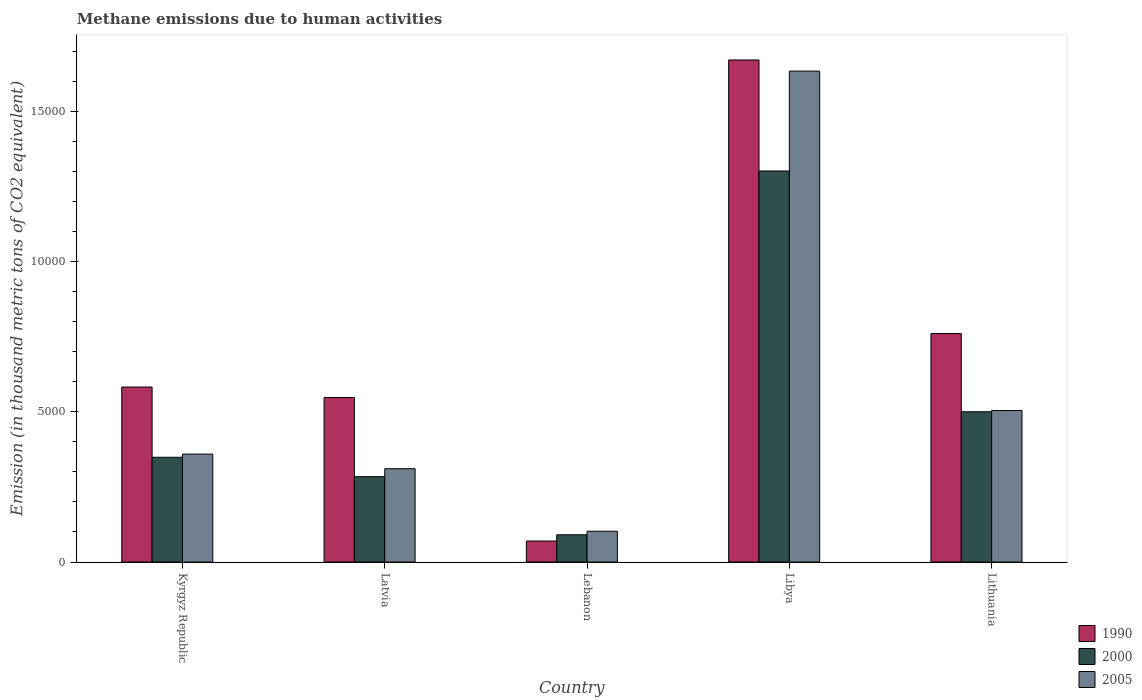How many different coloured bars are there?
Your response must be concise. 3. How many bars are there on the 5th tick from the left?
Your answer should be very brief. 3. How many bars are there on the 4th tick from the right?
Provide a short and direct response. 3. What is the label of the 4th group of bars from the left?
Keep it short and to the point. Libya. What is the amount of methane emitted in 1990 in Latvia?
Ensure brevity in your answer.  5472.8. Across all countries, what is the maximum amount of methane emitted in 2000?
Provide a short and direct response. 1.30e+04. Across all countries, what is the minimum amount of methane emitted in 2005?
Give a very brief answer. 1024.8. In which country was the amount of methane emitted in 2000 maximum?
Your response must be concise. Libya. In which country was the amount of methane emitted in 1990 minimum?
Offer a very short reply. Lebanon. What is the total amount of methane emitted in 2005 in the graph?
Your answer should be very brief. 2.91e+04. What is the difference between the amount of methane emitted in 2000 in Lebanon and that in Libya?
Keep it short and to the point. -1.21e+04. What is the difference between the amount of methane emitted in 2005 in Libya and the amount of methane emitted in 1990 in Latvia?
Offer a terse response. 1.09e+04. What is the average amount of methane emitted in 2005 per country?
Provide a short and direct response. 5819.52. What is the difference between the amount of methane emitted of/in 1990 and amount of methane emitted of/in 2005 in Lebanon?
Your answer should be compact. -325.8. In how many countries, is the amount of methane emitted in 2005 greater than 8000 thousand metric tons?
Your answer should be compact. 1. What is the ratio of the amount of methane emitted in 2000 in Latvia to that in Lebanon?
Provide a short and direct response. 3.13. Is the difference between the amount of methane emitted in 1990 in Libya and Lithuania greater than the difference between the amount of methane emitted in 2005 in Libya and Lithuania?
Your response must be concise. No. What is the difference between the highest and the second highest amount of methane emitted in 2005?
Offer a very short reply. -1.13e+04. What is the difference between the highest and the lowest amount of methane emitted in 1990?
Offer a very short reply. 1.60e+04. Is the sum of the amount of methane emitted in 2005 in Libya and Lithuania greater than the maximum amount of methane emitted in 2000 across all countries?
Offer a terse response. Yes. What does the 2nd bar from the left in Latvia represents?
Your answer should be very brief. 2000. How many bars are there?
Your answer should be very brief. 15. Does the graph contain any zero values?
Provide a succinct answer. No. How many legend labels are there?
Offer a very short reply. 3. How are the legend labels stacked?
Offer a terse response. Vertical. What is the title of the graph?
Keep it short and to the point. Methane emissions due to human activities. What is the label or title of the Y-axis?
Provide a short and direct response. Emission (in thousand metric tons of CO2 equivalent). What is the Emission (in thousand metric tons of CO2 equivalent) of 1990 in Kyrgyz Republic?
Give a very brief answer. 5822.6. What is the Emission (in thousand metric tons of CO2 equivalent) of 2000 in Kyrgyz Republic?
Ensure brevity in your answer.  3485.8. What is the Emission (in thousand metric tons of CO2 equivalent) of 2005 in Kyrgyz Republic?
Ensure brevity in your answer.  3591.3. What is the Emission (in thousand metric tons of CO2 equivalent) in 1990 in Latvia?
Offer a very short reply. 5472.8. What is the Emission (in thousand metric tons of CO2 equivalent) of 2000 in Latvia?
Offer a terse response. 2840. What is the Emission (in thousand metric tons of CO2 equivalent) in 2005 in Latvia?
Give a very brief answer. 3105. What is the Emission (in thousand metric tons of CO2 equivalent) of 1990 in Lebanon?
Provide a short and direct response. 699. What is the Emission (in thousand metric tons of CO2 equivalent) of 2000 in Lebanon?
Your answer should be very brief. 906.6. What is the Emission (in thousand metric tons of CO2 equivalent) in 2005 in Lebanon?
Provide a short and direct response. 1024.8. What is the Emission (in thousand metric tons of CO2 equivalent) in 1990 in Libya?
Offer a very short reply. 1.67e+04. What is the Emission (in thousand metric tons of CO2 equivalent) of 2000 in Libya?
Your answer should be very brief. 1.30e+04. What is the Emission (in thousand metric tons of CO2 equivalent) in 2005 in Libya?
Provide a succinct answer. 1.63e+04. What is the Emission (in thousand metric tons of CO2 equivalent) of 1990 in Lithuania?
Your answer should be very brief. 7603.6. What is the Emission (in thousand metric tons of CO2 equivalent) of 2000 in Lithuania?
Keep it short and to the point. 5000.2. What is the Emission (in thousand metric tons of CO2 equivalent) of 2005 in Lithuania?
Offer a terse response. 5042.2. Across all countries, what is the maximum Emission (in thousand metric tons of CO2 equivalent) in 1990?
Keep it short and to the point. 1.67e+04. Across all countries, what is the maximum Emission (in thousand metric tons of CO2 equivalent) in 2000?
Your answer should be very brief. 1.30e+04. Across all countries, what is the maximum Emission (in thousand metric tons of CO2 equivalent) in 2005?
Your answer should be compact. 1.63e+04. Across all countries, what is the minimum Emission (in thousand metric tons of CO2 equivalent) of 1990?
Provide a short and direct response. 699. Across all countries, what is the minimum Emission (in thousand metric tons of CO2 equivalent) in 2000?
Keep it short and to the point. 906.6. Across all countries, what is the minimum Emission (in thousand metric tons of CO2 equivalent) of 2005?
Offer a terse response. 1024.8. What is the total Emission (in thousand metric tons of CO2 equivalent) of 1990 in the graph?
Your answer should be very brief. 3.63e+04. What is the total Emission (in thousand metric tons of CO2 equivalent) of 2000 in the graph?
Provide a short and direct response. 2.52e+04. What is the total Emission (in thousand metric tons of CO2 equivalent) of 2005 in the graph?
Provide a succinct answer. 2.91e+04. What is the difference between the Emission (in thousand metric tons of CO2 equivalent) in 1990 in Kyrgyz Republic and that in Latvia?
Provide a short and direct response. 349.8. What is the difference between the Emission (in thousand metric tons of CO2 equivalent) in 2000 in Kyrgyz Republic and that in Latvia?
Make the answer very short. 645.8. What is the difference between the Emission (in thousand metric tons of CO2 equivalent) in 2005 in Kyrgyz Republic and that in Latvia?
Provide a short and direct response. 486.3. What is the difference between the Emission (in thousand metric tons of CO2 equivalent) in 1990 in Kyrgyz Republic and that in Lebanon?
Offer a terse response. 5123.6. What is the difference between the Emission (in thousand metric tons of CO2 equivalent) in 2000 in Kyrgyz Republic and that in Lebanon?
Offer a terse response. 2579.2. What is the difference between the Emission (in thousand metric tons of CO2 equivalent) in 2005 in Kyrgyz Republic and that in Lebanon?
Keep it short and to the point. 2566.5. What is the difference between the Emission (in thousand metric tons of CO2 equivalent) of 1990 in Kyrgyz Republic and that in Libya?
Make the answer very short. -1.09e+04. What is the difference between the Emission (in thousand metric tons of CO2 equivalent) of 2000 in Kyrgyz Republic and that in Libya?
Make the answer very short. -9525.3. What is the difference between the Emission (in thousand metric tons of CO2 equivalent) in 2005 in Kyrgyz Republic and that in Libya?
Keep it short and to the point. -1.27e+04. What is the difference between the Emission (in thousand metric tons of CO2 equivalent) in 1990 in Kyrgyz Republic and that in Lithuania?
Provide a succinct answer. -1781. What is the difference between the Emission (in thousand metric tons of CO2 equivalent) of 2000 in Kyrgyz Republic and that in Lithuania?
Keep it short and to the point. -1514.4. What is the difference between the Emission (in thousand metric tons of CO2 equivalent) in 2005 in Kyrgyz Republic and that in Lithuania?
Your answer should be compact. -1450.9. What is the difference between the Emission (in thousand metric tons of CO2 equivalent) of 1990 in Latvia and that in Lebanon?
Offer a terse response. 4773.8. What is the difference between the Emission (in thousand metric tons of CO2 equivalent) in 2000 in Latvia and that in Lebanon?
Make the answer very short. 1933.4. What is the difference between the Emission (in thousand metric tons of CO2 equivalent) of 2005 in Latvia and that in Lebanon?
Provide a short and direct response. 2080.2. What is the difference between the Emission (in thousand metric tons of CO2 equivalent) in 1990 in Latvia and that in Libya?
Ensure brevity in your answer.  -1.12e+04. What is the difference between the Emission (in thousand metric tons of CO2 equivalent) of 2000 in Latvia and that in Libya?
Keep it short and to the point. -1.02e+04. What is the difference between the Emission (in thousand metric tons of CO2 equivalent) of 2005 in Latvia and that in Libya?
Keep it short and to the point. -1.32e+04. What is the difference between the Emission (in thousand metric tons of CO2 equivalent) in 1990 in Latvia and that in Lithuania?
Keep it short and to the point. -2130.8. What is the difference between the Emission (in thousand metric tons of CO2 equivalent) in 2000 in Latvia and that in Lithuania?
Give a very brief answer. -2160.2. What is the difference between the Emission (in thousand metric tons of CO2 equivalent) of 2005 in Latvia and that in Lithuania?
Make the answer very short. -1937.2. What is the difference between the Emission (in thousand metric tons of CO2 equivalent) in 1990 in Lebanon and that in Libya?
Give a very brief answer. -1.60e+04. What is the difference between the Emission (in thousand metric tons of CO2 equivalent) of 2000 in Lebanon and that in Libya?
Offer a terse response. -1.21e+04. What is the difference between the Emission (in thousand metric tons of CO2 equivalent) of 2005 in Lebanon and that in Libya?
Give a very brief answer. -1.53e+04. What is the difference between the Emission (in thousand metric tons of CO2 equivalent) in 1990 in Lebanon and that in Lithuania?
Your answer should be very brief. -6904.6. What is the difference between the Emission (in thousand metric tons of CO2 equivalent) in 2000 in Lebanon and that in Lithuania?
Give a very brief answer. -4093.6. What is the difference between the Emission (in thousand metric tons of CO2 equivalent) in 2005 in Lebanon and that in Lithuania?
Provide a succinct answer. -4017.4. What is the difference between the Emission (in thousand metric tons of CO2 equivalent) in 1990 in Libya and that in Lithuania?
Give a very brief answer. 9100.8. What is the difference between the Emission (in thousand metric tons of CO2 equivalent) in 2000 in Libya and that in Lithuania?
Offer a terse response. 8010.9. What is the difference between the Emission (in thousand metric tons of CO2 equivalent) of 2005 in Libya and that in Lithuania?
Your answer should be very brief. 1.13e+04. What is the difference between the Emission (in thousand metric tons of CO2 equivalent) of 1990 in Kyrgyz Republic and the Emission (in thousand metric tons of CO2 equivalent) of 2000 in Latvia?
Your answer should be very brief. 2982.6. What is the difference between the Emission (in thousand metric tons of CO2 equivalent) of 1990 in Kyrgyz Republic and the Emission (in thousand metric tons of CO2 equivalent) of 2005 in Latvia?
Your response must be concise. 2717.6. What is the difference between the Emission (in thousand metric tons of CO2 equivalent) of 2000 in Kyrgyz Republic and the Emission (in thousand metric tons of CO2 equivalent) of 2005 in Latvia?
Provide a succinct answer. 380.8. What is the difference between the Emission (in thousand metric tons of CO2 equivalent) of 1990 in Kyrgyz Republic and the Emission (in thousand metric tons of CO2 equivalent) of 2000 in Lebanon?
Keep it short and to the point. 4916. What is the difference between the Emission (in thousand metric tons of CO2 equivalent) in 1990 in Kyrgyz Republic and the Emission (in thousand metric tons of CO2 equivalent) in 2005 in Lebanon?
Keep it short and to the point. 4797.8. What is the difference between the Emission (in thousand metric tons of CO2 equivalent) in 2000 in Kyrgyz Republic and the Emission (in thousand metric tons of CO2 equivalent) in 2005 in Lebanon?
Ensure brevity in your answer.  2461. What is the difference between the Emission (in thousand metric tons of CO2 equivalent) in 1990 in Kyrgyz Republic and the Emission (in thousand metric tons of CO2 equivalent) in 2000 in Libya?
Your response must be concise. -7188.5. What is the difference between the Emission (in thousand metric tons of CO2 equivalent) of 1990 in Kyrgyz Republic and the Emission (in thousand metric tons of CO2 equivalent) of 2005 in Libya?
Give a very brief answer. -1.05e+04. What is the difference between the Emission (in thousand metric tons of CO2 equivalent) in 2000 in Kyrgyz Republic and the Emission (in thousand metric tons of CO2 equivalent) in 2005 in Libya?
Your response must be concise. -1.28e+04. What is the difference between the Emission (in thousand metric tons of CO2 equivalent) of 1990 in Kyrgyz Republic and the Emission (in thousand metric tons of CO2 equivalent) of 2000 in Lithuania?
Offer a terse response. 822.4. What is the difference between the Emission (in thousand metric tons of CO2 equivalent) in 1990 in Kyrgyz Republic and the Emission (in thousand metric tons of CO2 equivalent) in 2005 in Lithuania?
Ensure brevity in your answer.  780.4. What is the difference between the Emission (in thousand metric tons of CO2 equivalent) of 2000 in Kyrgyz Republic and the Emission (in thousand metric tons of CO2 equivalent) of 2005 in Lithuania?
Provide a succinct answer. -1556.4. What is the difference between the Emission (in thousand metric tons of CO2 equivalent) of 1990 in Latvia and the Emission (in thousand metric tons of CO2 equivalent) of 2000 in Lebanon?
Offer a very short reply. 4566.2. What is the difference between the Emission (in thousand metric tons of CO2 equivalent) of 1990 in Latvia and the Emission (in thousand metric tons of CO2 equivalent) of 2005 in Lebanon?
Ensure brevity in your answer.  4448. What is the difference between the Emission (in thousand metric tons of CO2 equivalent) of 2000 in Latvia and the Emission (in thousand metric tons of CO2 equivalent) of 2005 in Lebanon?
Make the answer very short. 1815.2. What is the difference between the Emission (in thousand metric tons of CO2 equivalent) of 1990 in Latvia and the Emission (in thousand metric tons of CO2 equivalent) of 2000 in Libya?
Offer a very short reply. -7538.3. What is the difference between the Emission (in thousand metric tons of CO2 equivalent) of 1990 in Latvia and the Emission (in thousand metric tons of CO2 equivalent) of 2005 in Libya?
Provide a succinct answer. -1.09e+04. What is the difference between the Emission (in thousand metric tons of CO2 equivalent) in 2000 in Latvia and the Emission (in thousand metric tons of CO2 equivalent) in 2005 in Libya?
Make the answer very short. -1.35e+04. What is the difference between the Emission (in thousand metric tons of CO2 equivalent) in 1990 in Latvia and the Emission (in thousand metric tons of CO2 equivalent) in 2000 in Lithuania?
Keep it short and to the point. 472.6. What is the difference between the Emission (in thousand metric tons of CO2 equivalent) in 1990 in Latvia and the Emission (in thousand metric tons of CO2 equivalent) in 2005 in Lithuania?
Provide a short and direct response. 430.6. What is the difference between the Emission (in thousand metric tons of CO2 equivalent) in 2000 in Latvia and the Emission (in thousand metric tons of CO2 equivalent) in 2005 in Lithuania?
Provide a short and direct response. -2202.2. What is the difference between the Emission (in thousand metric tons of CO2 equivalent) of 1990 in Lebanon and the Emission (in thousand metric tons of CO2 equivalent) of 2000 in Libya?
Provide a short and direct response. -1.23e+04. What is the difference between the Emission (in thousand metric tons of CO2 equivalent) in 1990 in Lebanon and the Emission (in thousand metric tons of CO2 equivalent) in 2005 in Libya?
Provide a succinct answer. -1.56e+04. What is the difference between the Emission (in thousand metric tons of CO2 equivalent) of 2000 in Lebanon and the Emission (in thousand metric tons of CO2 equivalent) of 2005 in Libya?
Your response must be concise. -1.54e+04. What is the difference between the Emission (in thousand metric tons of CO2 equivalent) of 1990 in Lebanon and the Emission (in thousand metric tons of CO2 equivalent) of 2000 in Lithuania?
Your response must be concise. -4301.2. What is the difference between the Emission (in thousand metric tons of CO2 equivalent) in 1990 in Lebanon and the Emission (in thousand metric tons of CO2 equivalent) in 2005 in Lithuania?
Your response must be concise. -4343.2. What is the difference between the Emission (in thousand metric tons of CO2 equivalent) in 2000 in Lebanon and the Emission (in thousand metric tons of CO2 equivalent) in 2005 in Lithuania?
Your answer should be compact. -4135.6. What is the difference between the Emission (in thousand metric tons of CO2 equivalent) of 1990 in Libya and the Emission (in thousand metric tons of CO2 equivalent) of 2000 in Lithuania?
Provide a short and direct response. 1.17e+04. What is the difference between the Emission (in thousand metric tons of CO2 equivalent) of 1990 in Libya and the Emission (in thousand metric tons of CO2 equivalent) of 2005 in Lithuania?
Keep it short and to the point. 1.17e+04. What is the difference between the Emission (in thousand metric tons of CO2 equivalent) in 2000 in Libya and the Emission (in thousand metric tons of CO2 equivalent) in 2005 in Lithuania?
Provide a short and direct response. 7968.9. What is the average Emission (in thousand metric tons of CO2 equivalent) of 1990 per country?
Provide a short and direct response. 7260.48. What is the average Emission (in thousand metric tons of CO2 equivalent) of 2000 per country?
Provide a succinct answer. 5048.74. What is the average Emission (in thousand metric tons of CO2 equivalent) of 2005 per country?
Give a very brief answer. 5819.52. What is the difference between the Emission (in thousand metric tons of CO2 equivalent) in 1990 and Emission (in thousand metric tons of CO2 equivalent) in 2000 in Kyrgyz Republic?
Your response must be concise. 2336.8. What is the difference between the Emission (in thousand metric tons of CO2 equivalent) in 1990 and Emission (in thousand metric tons of CO2 equivalent) in 2005 in Kyrgyz Republic?
Your answer should be compact. 2231.3. What is the difference between the Emission (in thousand metric tons of CO2 equivalent) in 2000 and Emission (in thousand metric tons of CO2 equivalent) in 2005 in Kyrgyz Republic?
Keep it short and to the point. -105.5. What is the difference between the Emission (in thousand metric tons of CO2 equivalent) in 1990 and Emission (in thousand metric tons of CO2 equivalent) in 2000 in Latvia?
Offer a terse response. 2632.8. What is the difference between the Emission (in thousand metric tons of CO2 equivalent) of 1990 and Emission (in thousand metric tons of CO2 equivalent) of 2005 in Latvia?
Your answer should be compact. 2367.8. What is the difference between the Emission (in thousand metric tons of CO2 equivalent) in 2000 and Emission (in thousand metric tons of CO2 equivalent) in 2005 in Latvia?
Provide a succinct answer. -265. What is the difference between the Emission (in thousand metric tons of CO2 equivalent) of 1990 and Emission (in thousand metric tons of CO2 equivalent) of 2000 in Lebanon?
Offer a terse response. -207.6. What is the difference between the Emission (in thousand metric tons of CO2 equivalent) in 1990 and Emission (in thousand metric tons of CO2 equivalent) in 2005 in Lebanon?
Your answer should be compact. -325.8. What is the difference between the Emission (in thousand metric tons of CO2 equivalent) of 2000 and Emission (in thousand metric tons of CO2 equivalent) of 2005 in Lebanon?
Provide a succinct answer. -118.2. What is the difference between the Emission (in thousand metric tons of CO2 equivalent) in 1990 and Emission (in thousand metric tons of CO2 equivalent) in 2000 in Libya?
Ensure brevity in your answer.  3693.3. What is the difference between the Emission (in thousand metric tons of CO2 equivalent) of 1990 and Emission (in thousand metric tons of CO2 equivalent) of 2005 in Libya?
Your answer should be very brief. 370.1. What is the difference between the Emission (in thousand metric tons of CO2 equivalent) in 2000 and Emission (in thousand metric tons of CO2 equivalent) in 2005 in Libya?
Offer a very short reply. -3323.2. What is the difference between the Emission (in thousand metric tons of CO2 equivalent) in 1990 and Emission (in thousand metric tons of CO2 equivalent) in 2000 in Lithuania?
Provide a short and direct response. 2603.4. What is the difference between the Emission (in thousand metric tons of CO2 equivalent) of 1990 and Emission (in thousand metric tons of CO2 equivalent) of 2005 in Lithuania?
Ensure brevity in your answer.  2561.4. What is the difference between the Emission (in thousand metric tons of CO2 equivalent) in 2000 and Emission (in thousand metric tons of CO2 equivalent) in 2005 in Lithuania?
Your response must be concise. -42. What is the ratio of the Emission (in thousand metric tons of CO2 equivalent) of 1990 in Kyrgyz Republic to that in Latvia?
Your answer should be compact. 1.06. What is the ratio of the Emission (in thousand metric tons of CO2 equivalent) of 2000 in Kyrgyz Republic to that in Latvia?
Provide a short and direct response. 1.23. What is the ratio of the Emission (in thousand metric tons of CO2 equivalent) in 2005 in Kyrgyz Republic to that in Latvia?
Your response must be concise. 1.16. What is the ratio of the Emission (in thousand metric tons of CO2 equivalent) in 1990 in Kyrgyz Republic to that in Lebanon?
Your answer should be compact. 8.33. What is the ratio of the Emission (in thousand metric tons of CO2 equivalent) of 2000 in Kyrgyz Republic to that in Lebanon?
Provide a short and direct response. 3.84. What is the ratio of the Emission (in thousand metric tons of CO2 equivalent) in 2005 in Kyrgyz Republic to that in Lebanon?
Offer a terse response. 3.5. What is the ratio of the Emission (in thousand metric tons of CO2 equivalent) in 1990 in Kyrgyz Republic to that in Libya?
Provide a succinct answer. 0.35. What is the ratio of the Emission (in thousand metric tons of CO2 equivalent) of 2000 in Kyrgyz Republic to that in Libya?
Your answer should be very brief. 0.27. What is the ratio of the Emission (in thousand metric tons of CO2 equivalent) in 2005 in Kyrgyz Republic to that in Libya?
Your response must be concise. 0.22. What is the ratio of the Emission (in thousand metric tons of CO2 equivalent) of 1990 in Kyrgyz Republic to that in Lithuania?
Your answer should be compact. 0.77. What is the ratio of the Emission (in thousand metric tons of CO2 equivalent) in 2000 in Kyrgyz Republic to that in Lithuania?
Ensure brevity in your answer.  0.7. What is the ratio of the Emission (in thousand metric tons of CO2 equivalent) of 2005 in Kyrgyz Republic to that in Lithuania?
Your response must be concise. 0.71. What is the ratio of the Emission (in thousand metric tons of CO2 equivalent) of 1990 in Latvia to that in Lebanon?
Provide a short and direct response. 7.83. What is the ratio of the Emission (in thousand metric tons of CO2 equivalent) in 2000 in Latvia to that in Lebanon?
Your answer should be compact. 3.13. What is the ratio of the Emission (in thousand metric tons of CO2 equivalent) in 2005 in Latvia to that in Lebanon?
Provide a short and direct response. 3.03. What is the ratio of the Emission (in thousand metric tons of CO2 equivalent) of 1990 in Latvia to that in Libya?
Keep it short and to the point. 0.33. What is the ratio of the Emission (in thousand metric tons of CO2 equivalent) of 2000 in Latvia to that in Libya?
Provide a short and direct response. 0.22. What is the ratio of the Emission (in thousand metric tons of CO2 equivalent) of 2005 in Latvia to that in Libya?
Your answer should be compact. 0.19. What is the ratio of the Emission (in thousand metric tons of CO2 equivalent) of 1990 in Latvia to that in Lithuania?
Make the answer very short. 0.72. What is the ratio of the Emission (in thousand metric tons of CO2 equivalent) in 2000 in Latvia to that in Lithuania?
Provide a short and direct response. 0.57. What is the ratio of the Emission (in thousand metric tons of CO2 equivalent) of 2005 in Latvia to that in Lithuania?
Ensure brevity in your answer.  0.62. What is the ratio of the Emission (in thousand metric tons of CO2 equivalent) in 1990 in Lebanon to that in Libya?
Ensure brevity in your answer.  0.04. What is the ratio of the Emission (in thousand metric tons of CO2 equivalent) of 2000 in Lebanon to that in Libya?
Provide a short and direct response. 0.07. What is the ratio of the Emission (in thousand metric tons of CO2 equivalent) of 2005 in Lebanon to that in Libya?
Your answer should be very brief. 0.06. What is the ratio of the Emission (in thousand metric tons of CO2 equivalent) in 1990 in Lebanon to that in Lithuania?
Your response must be concise. 0.09. What is the ratio of the Emission (in thousand metric tons of CO2 equivalent) of 2000 in Lebanon to that in Lithuania?
Provide a succinct answer. 0.18. What is the ratio of the Emission (in thousand metric tons of CO2 equivalent) in 2005 in Lebanon to that in Lithuania?
Offer a terse response. 0.2. What is the ratio of the Emission (in thousand metric tons of CO2 equivalent) of 1990 in Libya to that in Lithuania?
Provide a short and direct response. 2.2. What is the ratio of the Emission (in thousand metric tons of CO2 equivalent) in 2000 in Libya to that in Lithuania?
Provide a short and direct response. 2.6. What is the ratio of the Emission (in thousand metric tons of CO2 equivalent) of 2005 in Libya to that in Lithuania?
Offer a terse response. 3.24. What is the difference between the highest and the second highest Emission (in thousand metric tons of CO2 equivalent) of 1990?
Keep it short and to the point. 9100.8. What is the difference between the highest and the second highest Emission (in thousand metric tons of CO2 equivalent) of 2000?
Your answer should be very brief. 8010.9. What is the difference between the highest and the second highest Emission (in thousand metric tons of CO2 equivalent) of 2005?
Your answer should be very brief. 1.13e+04. What is the difference between the highest and the lowest Emission (in thousand metric tons of CO2 equivalent) in 1990?
Provide a succinct answer. 1.60e+04. What is the difference between the highest and the lowest Emission (in thousand metric tons of CO2 equivalent) of 2000?
Give a very brief answer. 1.21e+04. What is the difference between the highest and the lowest Emission (in thousand metric tons of CO2 equivalent) in 2005?
Keep it short and to the point. 1.53e+04. 